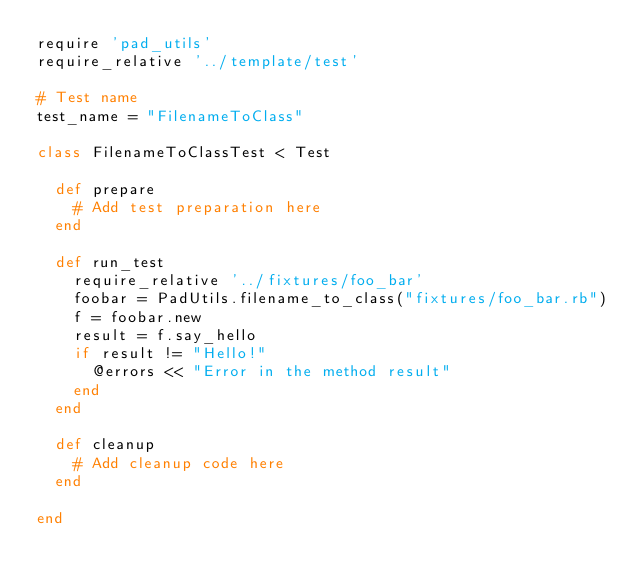<code> <loc_0><loc_0><loc_500><loc_500><_Ruby_>require 'pad_utils'
require_relative '../template/test'

# Test name
test_name = "FilenameToClass"

class FilenameToClassTest < Test

  def prepare
    # Add test preparation here
  end

  def run_test
    require_relative '../fixtures/foo_bar'
    foobar = PadUtils.filename_to_class("fixtures/foo_bar.rb")
    f = foobar.new
    result = f.say_hello
    if result != "Hello!"
      @errors << "Error in the method result"
    end
  end

  def cleanup
    # Add cleanup code here
  end

end
</code> 